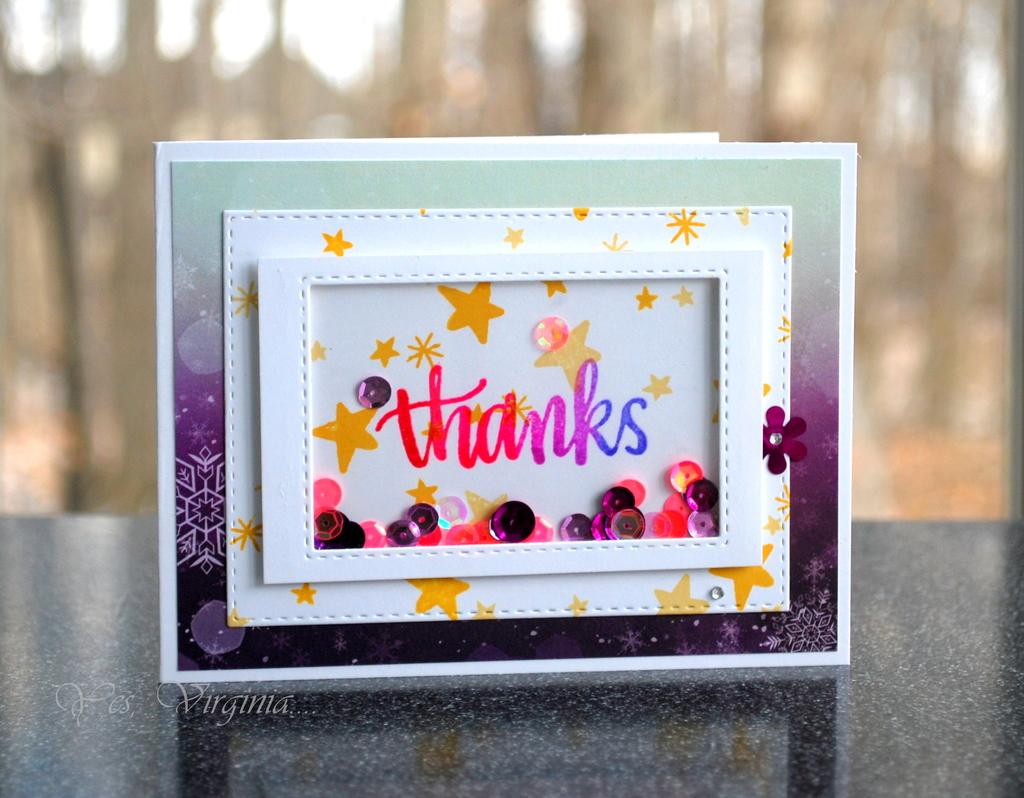<image>
Create a compact narrative representing the image presented. A framed picture of the word "thanks" in multiple colors. 